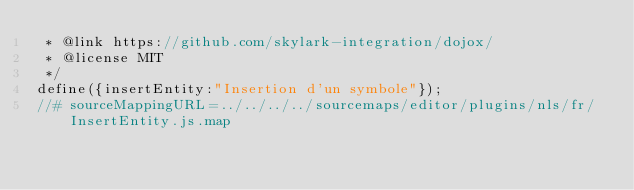<code> <loc_0><loc_0><loc_500><loc_500><_JavaScript_> * @link https://github.com/skylark-integration/dojox/
 * @license MIT
 */
define({insertEntity:"Insertion d'un symbole"});
//# sourceMappingURL=../../../../sourcemaps/editor/plugins/nls/fr/InsertEntity.js.map
</code> 